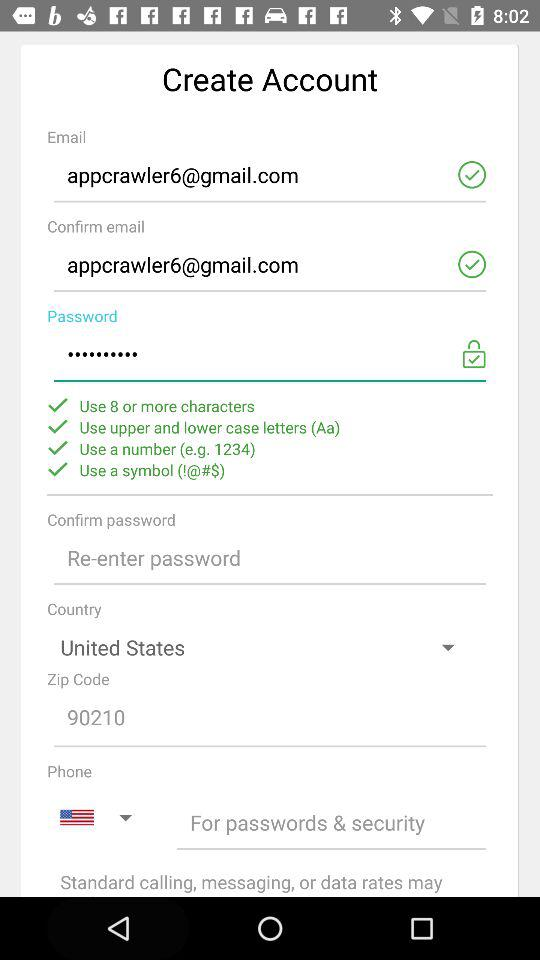How many symbol does a password have?
When the provided information is insufficient, respond with <no answer>. <no answer> 